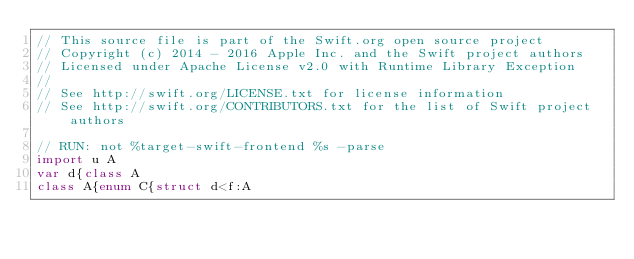Convert code to text. <code><loc_0><loc_0><loc_500><loc_500><_Swift_>// This source file is part of the Swift.org open source project
// Copyright (c) 2014 - 2016 Apple Inc. and the Swift project authors
// Licensed under Apache License v2.0 with Runtime Library Exception
//
// See http://swift.org/LICENSE.txt for license information
// See http://swift.org/CONTRIBUTORS.txt for the list of Swift project authors

// RUN: not %target-swift-frontend %s -parse
import u A
var d{class A
class A{enum C{struct d<f:A
</code> 